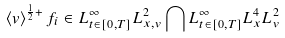<formula> <loc_0><loc_0><loc_500><loc_500>\left < v \right > ^ { \frac { 1 } { 2 } + } f _ { i } \in L ^ { \infty } _ { t \in [ 0 , T ] } L ^ { 2 } _ { x , v } \bigcap L ^ { \infty } _ { t \in [ 0 , T ] } L ^ { 4 } _ { x } L ^ { 2 } _ { v }</formula> 